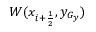<formula> <loc_0><loc_0><loc_500><loc_500>W ( x _ { i + \frac { 1 } { 2 } } , y _ { G _ { y } } )</formula> 